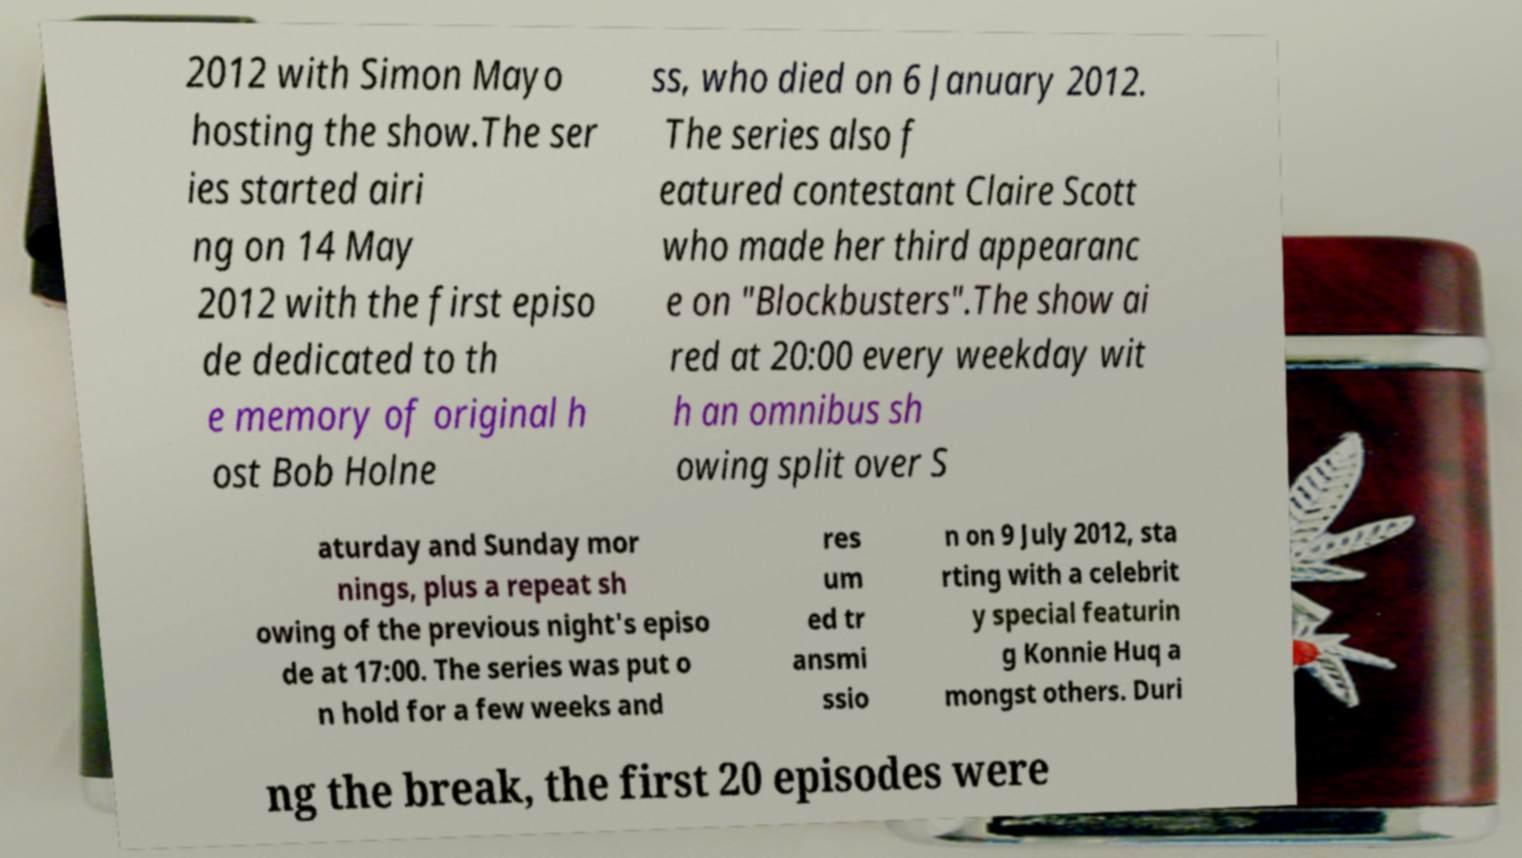Please read and relay the text visible in this image. What does it say? 2012 with Simon Mayo hosting the show.The ser ies started airi ng on 14 May 2012 with the first episo de dedicated to th e memory of original h ost Bob Holne ss, who died on 6 January 2012. The series also f eatured contestant Claire Scott who made her third appearanc e on "Blockbusters".The show ai red at 20:00 every weekday wit h an omnibus sh owing split over S aturday and Sunday mor nings, plus a repeat sh owing of the previous night's episo de at 17:00. The series was put o n hold for a few weeks and res um ed tr ansmi ssio n on 9 July 2012, sta rting with a celebrit y special featurin g Konnie Huq a mongst others. Duri ng the break, the first 20 episodes were 